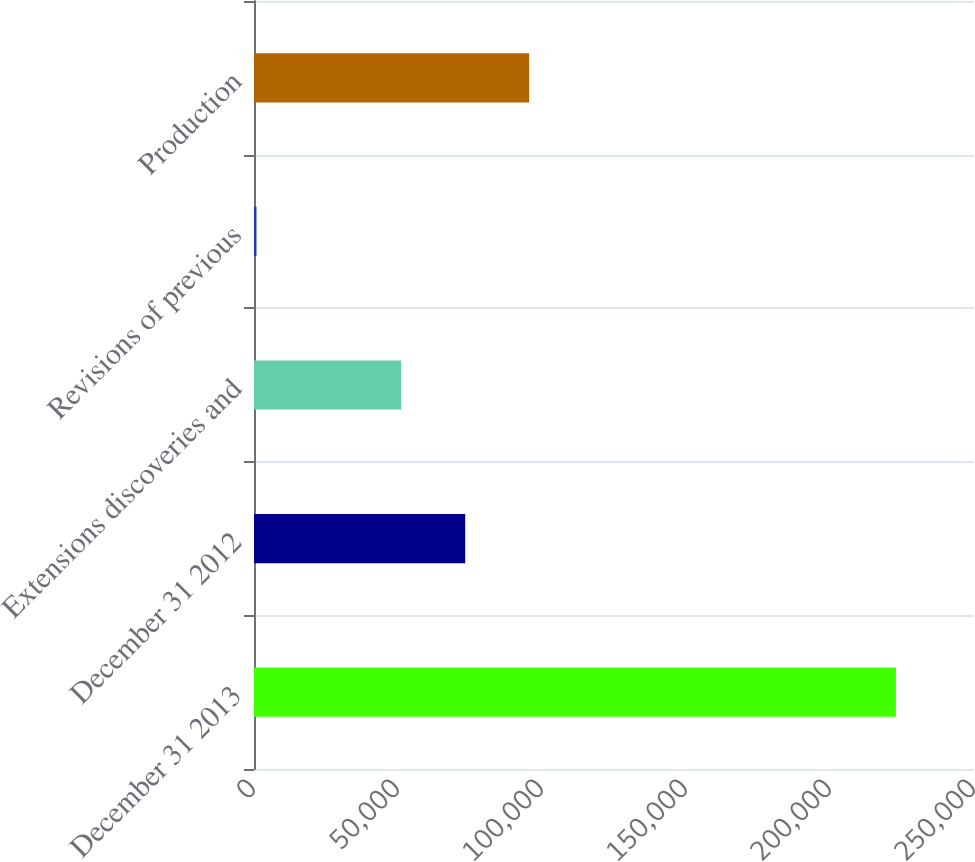Convert chart. <chart><loc_0><loc_0><loc_500><loc_500><bar_chart><fcel>December 31 2013<fcel>December 31 2012<fcel>Extensions discoveries and<fcel>Revisions of previous<fcel>Production<nl><fcel>222880<fcel>73337.1<fcel>51135<fcel>859<fcel>95539.2<nl></chart> 